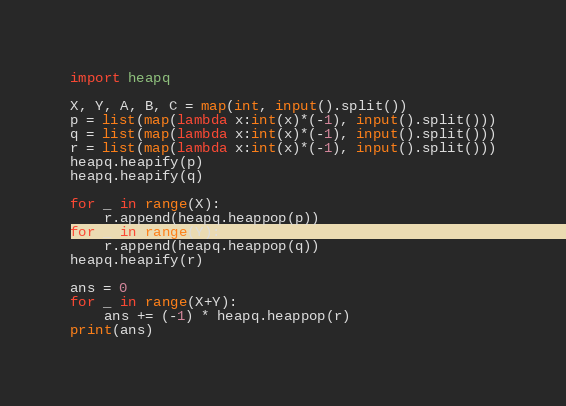Convert code to text. <code><loc_0><loc_0><loc_500><loc_500><_Python_>import heapq

X, Y, A, B, C = map(int, input().split())
p = list(map(lambda x:int(x)*(-1), input().split()))
q = list(map(lambda x:int(x)*(-1), input().split()))
r = list(map(lambda x:int(x)*(-1), input().split()))
heapq.heapify(p)
heapq.heapify(q)

for _ in range(X):
    r.append(heapq.heappop(p))
for _ in range(Y):
    r.append(heapq.heappop(q))
heapq.heapify(r)

ans = 0
for _ in range(X+Y):
    ans += (-1) * heapq.heappop(r)
print(ans)
</code> 